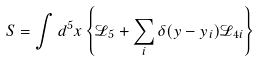Convert formula to latex. <formula><loc_0><loc_0><loc_500><loc_500>S = \int d ^ { 5 } x \left \{ \mathcal { L } _ { 5 } + \sum _ { i } \delta ( y - y _ { i } ) \mathcal { L } _ { 4 i } \right \}</formula> 